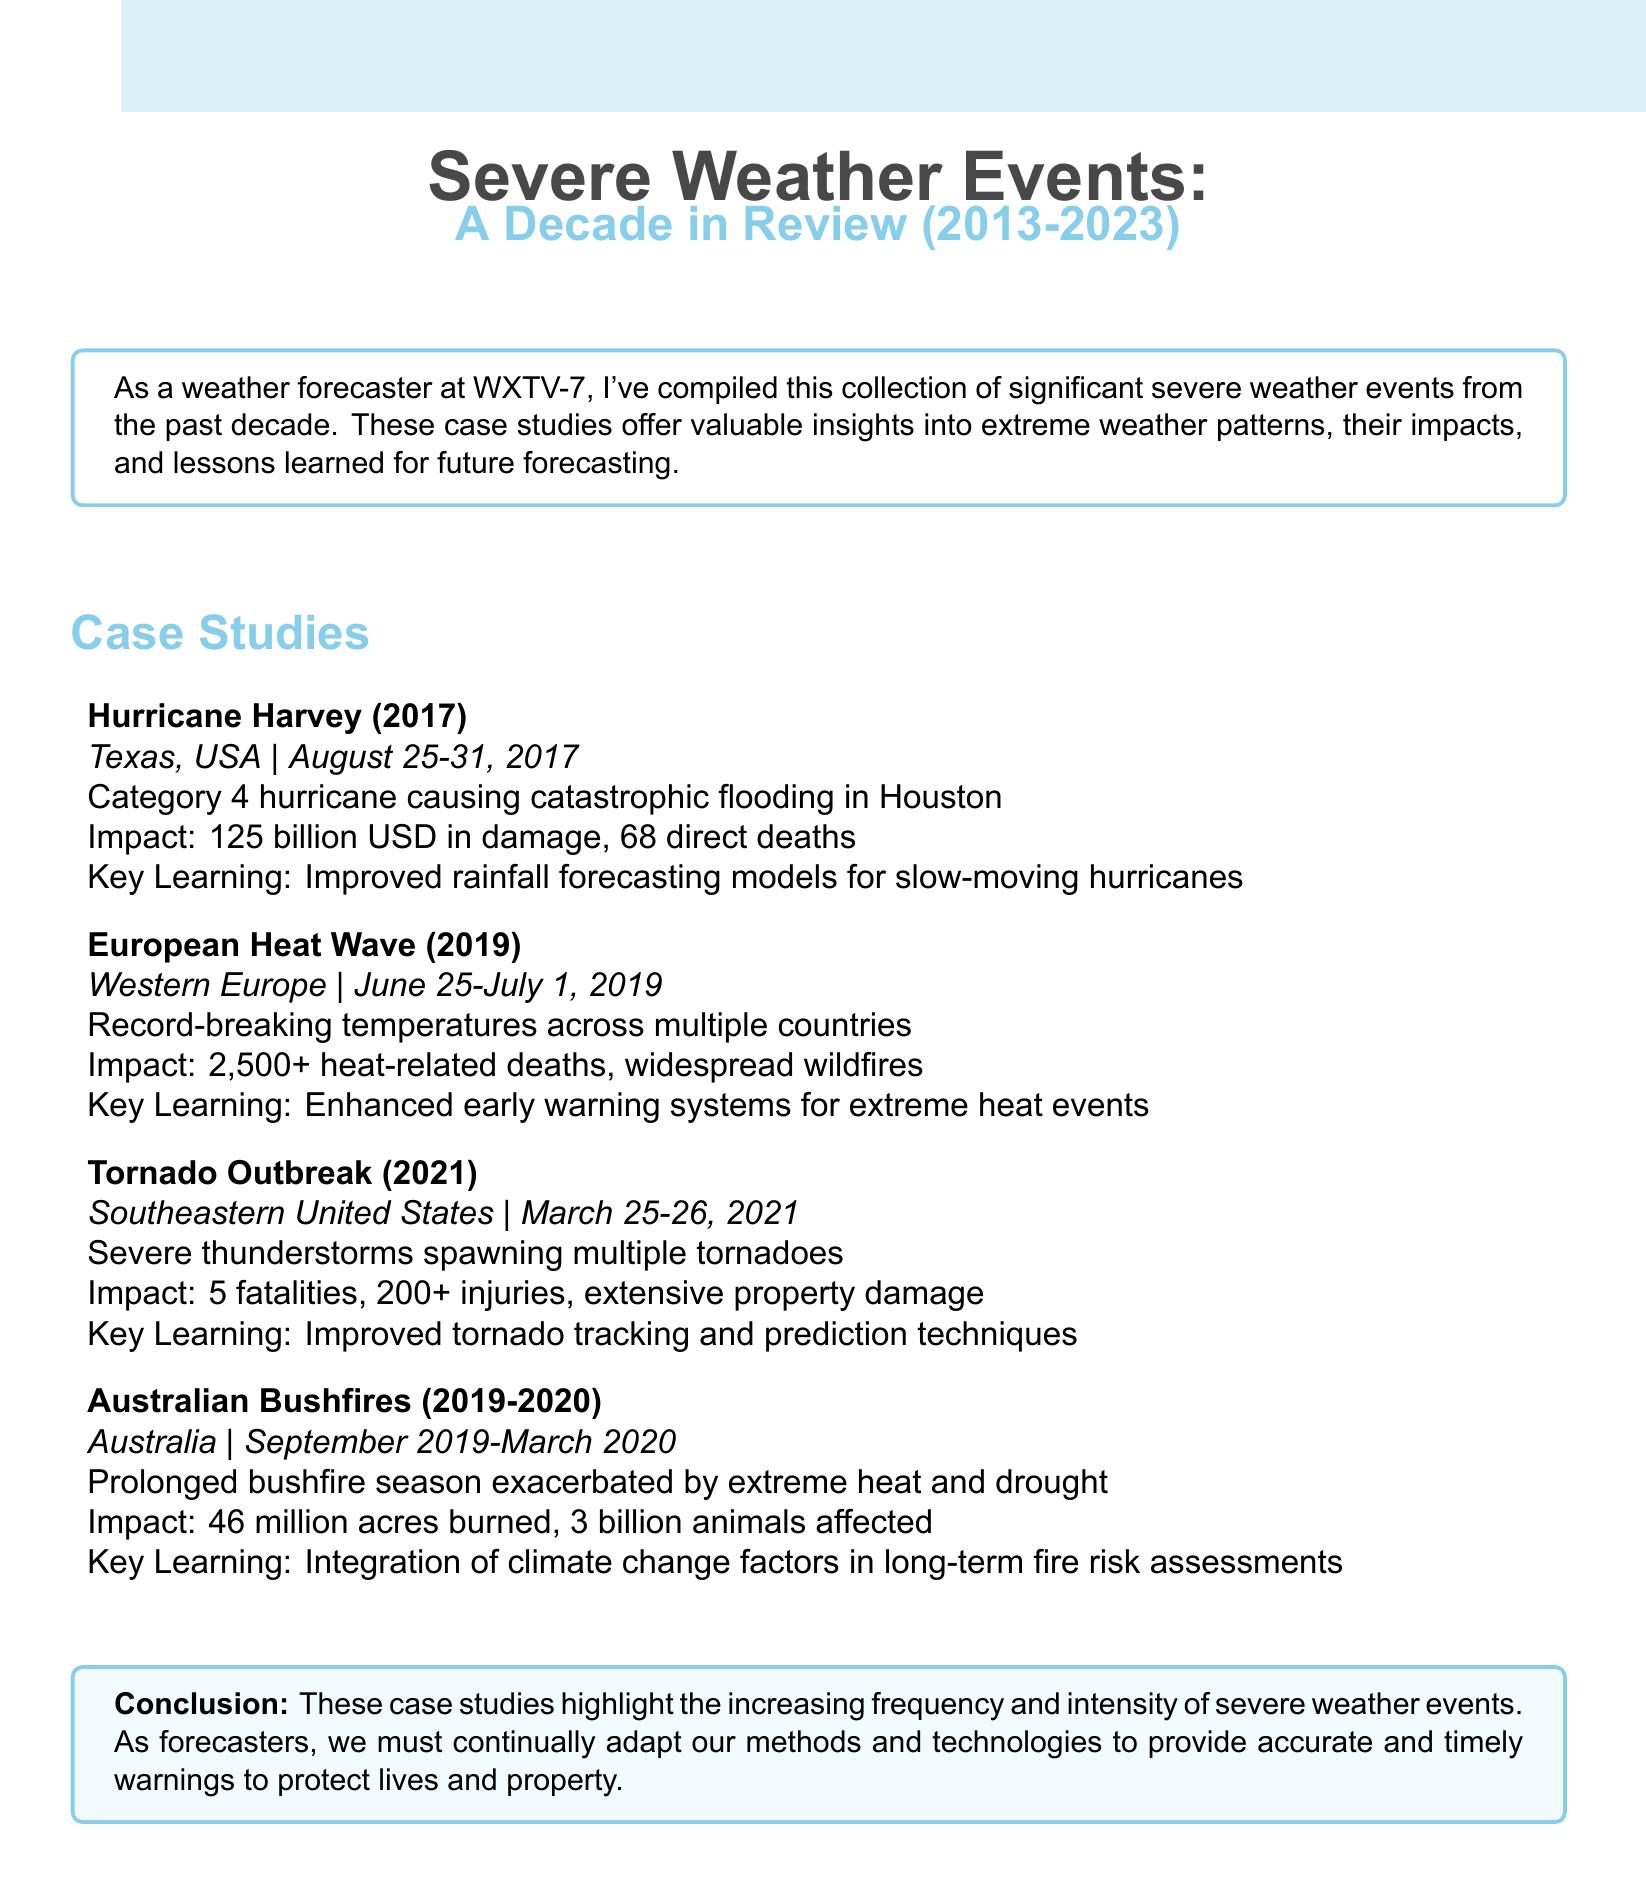What was the impact of Hurricane Harvey? The document states that Hurricane Harvey caused 125 billion USD in damage and resulted in 68 direct deaths.
Answer: 125 billion USD in damage, 68 direct deaths When did the European Heat Wave occur? The date range provided for the European Heat Wave case study is June 25 to July 1, 2019.
Answer: June 25-July 1, 2019 What was a key learning from the Tornado Outbreak? The key learning noted from the Tornado Outbreak case study was improved tornado tracking and prediction techniques.
Answer: Improved tornado tracking and prediction techniques How many acres were burned in the Australian Bushfires? The Australian Bushfires caused 46 million acres to be burned, according to the document.
Answer: 46 million acres What is the total number of heat-related deaths in the European Heat Wave? The document mentions that there were 2,500+ heat-related deaths during the European Heat Wave.
Answer: 2,500+ heat-related deaths What event is associated with damaging storms in March 2021? The document specifies the Tornado Outbreak as the event associated with damaging storms in March 2021.
Answer: Tornado Outbreak What was a significant impact of the Australian Bushfires? The document notes that 3 billion animals were affected by the Australian Bushfires.
Answer: 3 billion animals affected What improvement was made in rainfall forecasting after Hurricane Harvey? The document states that there was an improved rainfall forecasting model specifically for slow-moving hurricanes after Hurricane Harvey.
Answer: Improved rainfall forecasting models for slow-moving hurricanes 